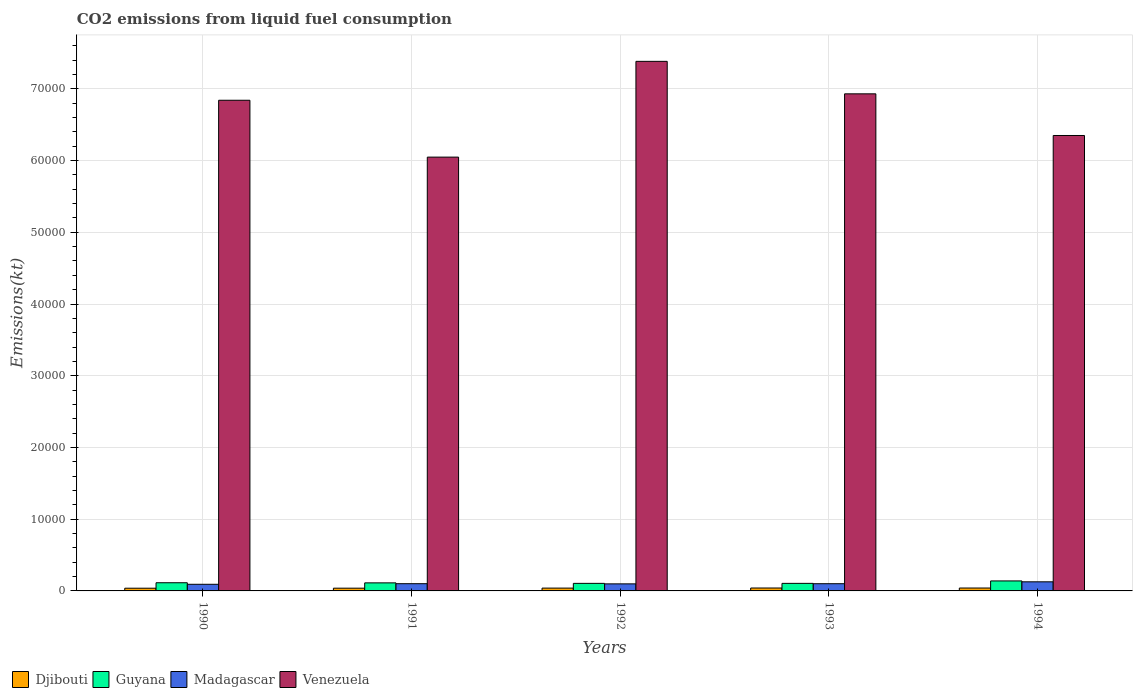How many groups of bars are there?
Offer a terse response. 5. Are the number of bars per tick equal to the number of legend labels?
Ensure brevity in your answer.  Yes. How many bars are there on the 2nd tick from the left?
Your response must be concise. 4. How many bars are there on the 1st tick from the right?
Give a very brief answer. 4. What is the amount of CO2 emitted in Madagascar in 1991?
Provide a short and direct response. 1008.42. Across all years, what is the maximum amount of CO2 emitted in Venezuela?
Offer a terse response. 7.38e+04. Across all years, what is the minimum amount of CO2 emitted in Djibouti?
Your answer should be compact. 377.7. What is the total amount of CO2 emitted in Djibouti in the graph?
Your response must be concise. 1961.85. What is the difference between the amount of CO2 emitted in Venezuela in 1992 and that in 1993?
Offer a very short reply. 4528.74. What is the difference between the amount of CO2 emitted in Djibouti in 1993 and the amount of CO2 emitted in Guyana in 1990?
Your answer should be very brief. -733.4. What is the average amount of CO2 emitted in Guyana per year?
Provide a succinct answer. 1152.17. In the year 1994, what is the difference between the amount of CO2 emitted in Venezuela and amount of CO2 emitted in Djibouti?
Ensure brevity in your answer.  6.31e+04. What is the ratio of the amount of CO2 emitted in Venezuela in 1990 to that in 1991?
Give a very brief answer. 1.13. What is the difference between the highest and the second highest amount of CO2 emitted in Venezuela?
Ensure brevity in your answer.  4528.74. What is the difference between the highest and the lowest amount of CO2 emitted in Madagascar?
Your answer should be compact. 344.7. Is it the case that in every year, the sum of the amount of CO2 emitted in Madagascar and amount of CO2 emitted in Venezuela is greater than the sum of amount of CO2 emitted in Djibouti and amount of CO2 emitted in Guyana?
Provide a short and direct response. Yes. What does the 3rd bar from the left in 1991 represents?
Keep it short and to the point. Madagascar. What does the 2nd bar from the right in 1990 represents?
Your answer should be very brief. Madagascar. Is it the case that in every year, the sum of the amount of CO2 emitted in Venezuela and amount of CO2 emitted in Madagascar is greater than the amount of CO2 emitted in Guyana?
Make the answer very short. Yes. How many bars are there?
Your answer should be compact. 20. Are all the bars in the graph horizontal?
Your answer should be very brief. No. How many years are there in the graph?
Provide a succinct answer. 5. Are the values on the major ticks of Y-axis written in scientific E-notation?
Ensure brevity in your answer.  No. How are the legend labels stacked?
Offer a very short reply. Horizontal. What is the title of the graph?
Ensure brevity in your answer.  CO2 emissions from liquid fuel consumption. Does "United States" appear as one of the legend labels in the graph?
Your response must be concise. No. What is the label or title of the X-axis?
Make the answer very short. Years. What is the label or title of the Y-axis?
Your answer should be compact. Emissions(kt). What is the Emissions(kt) of Djibouti in 1990?
Offer a terse response. 377.7. What is the Emissions(kt) of Guyana in 1990?
Offer a terse response. 1140.44. What is the Emissions(kt) in Madagascar in 1990?
Keep it short and to the point. 924.08. What is the Emissions(kt) of Venezuela in 1990?
Offer a terse response. 6.84e+04. What is the Emissions(kt) in Djibouti in 1991?
Make the answer very short. 381.37. What is the Emissions(kt) of Guyana in 1991?
Your answer should be compact. 1122.1. What is the Emissions(kt) of Madagascar in 1991?
Keep it short and to the point. 1008.42. What is the Emissions(kt) in Venezuela in 1991?
Your answer should be very brief. 6.05e+04. What is the Emissions(kt) of Djibouti in 1992?
Ensure brevity in your answer.  392.37. What is the Emissions(kt) of Guyana in 1992?
Your response must be concise. 1052.43. What is the Emissions(kt) in Madagascar in 1992?
Provide a succinct answer. 982.76. What is the Emissions(kt) of Venezuela in 1992?
Ensure brevity in your answer.  7.38e+04. What is the Emissions(kt) in Djibouti in 1993?
Offer a very short reply. 407.04. What is the Emissions(kt) in Guyana in 1993?
Your answer should be compact. 1052.43. What is the Emissions(kt) of Madagascar in 1993?
Keep it short and to the point. 1004.76. What is the Emissions(kt) of Venezuela in 1993?
Keep it short and to the point. 6.93e+04. What is the Emissions(kt) in Djibouti in 1994?
Your answer should be compact. 403.37. What is the Emissions(kt) in Guyana in 1994?
Give a very brief answer. 1393.46. What is the Emissions(kt) in Madagascar in 1994?
Provide a succinct answer. 1268.78. What is the Emissions(kt) of Venezuela in 1994?
Your answer should be compact. 6.35e+04. Across all years, what is the maximum Emissions(kt) in Djibouti?
Make the answer very short. 407.04. Across all years, what is the maximum Emissions(kt) in Guyana?
Offer a very short reply. 1393.46. Across all years, what is the maximum Emissions(kt) in Madagascar?
Provide a short and direct response. 1268.78. Across all years, what is the maximum Emissions(kt) in Venezuela?
Your answer should be compact. 7.38e+04. Across all years, what is the minimum Emissions(kt) in Djibouti?
Offer a terse response. 377.7. Across all years, what is the minimum Emissions(kt) of Guyana?
Offer a terse response. 1052.43. Across all years, what is the minimum Emissions(kt) of Madagascar?
Provide a succinct answer. 924.08. Across all years, what is the minimum Emissions(kt) in Venezuela?
Offer a very short reply. 6.05e+04. What is the total Emissions(kt) in Djibouti in the graph?
Ensure brevity in your answer.  1961.85. What is the total Emissions(kt) of Guyana in the graph?
Provide a short and direct response. 5760.86. What is the total Emissions(kt) of Madagascar in the graph?
Make the answer very short. 5188.81. What is the total Emissions(kt) of Venezuela in the graph?
Offer a very short reply. 3.36e+05. What is the difference between the Emissions(kt) in Djibouti in 1990 and that in 1991?
Offer a very short reply. -3.67. What is the difference between the Emissions(kt) of Guyana in 1990 and that in 1991?
Your answer should be compact. 18.34. What is the difference between the Emissions(kt) of Madagascar in 1990 and that in 1991?
Make the answer very short. -84.34. What is the difference between the Emissions(kt) in Venezuela in 1990 and that in 1991?
Make the answer very short. 7928.05. What is the difference between the Emissions(kt) in Djibouti in 1990 and that in 1992?
Your answer should be very brief. -14.67. What is the difference between the Emissions(kt) in Guyana in 1990 and that in 1992?
Keep it short and to the point. 88.01. What is the difference between the Emissions(kt) in Madagascar in 1990 and that in 1992?
Offer a terse response. -58.67. What is the difference between the Emissions(kt) in Venezuela in 1990 and that in 1992?
Your answer should be compact. -5423.49. What is the difference between the Emissions(kt) in Djibouti in 1990 and that in 1993?
Provide a succinct answer. -29.34. What is the difference between the Emissions(kt) of Guyana in 1990 and that in 1993?
Make the answer very short. 88.01. What is the difference between the Emissions(kt) of Madagascar in 1990 and that in 1993?
Offer a terse response. -80.67. What is the difference between the Emissions(kt) of Venezuela in 1990 and that in 1993?
Give a very brief answer. -894.75. What is the difference between the Emissions(kt) in Djibouti in 1990 and that in 1994?
Provide a short and direct response. -25.67. What is the difference between the Emissions(kt) of Guyana in 1990 and that in 1994?
Give a very brief answer. -253.02. What is the difference between the Emissions(kt) of Madagascar in 1990 and that in 1994?
Keep it short and to the point. -344.7. What is the difference between the Emissions(kt) of Venezuela in 1990 and that in 1994?
Your answer should be very brief. 4913.78. What is the difference between the Emissions(kt) of Djibouti in 1991 and that in 1992?
Your answer should be very brief. -11. What is the difference between the Emissions(kt) in Guyana in 1991 and that in 1992?
Ensure brevity in your answer.  69.67. What is the difference between the Emissions(kt) in Madagascar in 1991 and that in 1992?
Give a very brief answer. 25.67. What is the difference between the Emissions(kt) in Venezuela in 1991 and that in 1992?
Offer a very short reply. -1.34e+04. What is the difference between the Emissions(kt) of Djibouti in 1991 and that in 1993?
Offer a terse response. -25.67. What is the difference between the Emissions(kt) of Guyana in 1991 and that in 1993?
Make the answer very short. 69.67. What is the difference between the Emissions(kt) in Madagascar in 1991 and that in 1993?
Offer a very short reply. 3.67. What is the difference between the Emissions(kt) of Venezuela in 1991 and that in 1993?
Offer a very short reply. -8822.8. What is the difference between the Emissions(kt) in Djibouti in 1991 and that in 1994?
Keep it short and to the point. -22. What is the difference between the Emissions(kt) in Guyana in 1991 and that in 1994?
Your answer should be very brief. -271.36. What is the difference between the Emissions(kt) in Madagascar in 1991 and that in 1994?
Ensure brevity in your answer.  -260.36. What is the difference between the Emissions(kt) in Venezuela in 1991 and that in 1994?
Give a very brief answer. -3014.27. What is the difference between the Emissions(kt) of Djibouti in 1992 and that in 1993?
Your answer should be very brief. -14.67. What is the difference between the Emissions(kt) in Guyana in 1992 and that in 1993?
Offer a very short reply. 0. What is the difference between the Emissions(kt) in Madagascar in 1992 and that in 1993?
Offer a very short reply. -22. What is the difference between the Emissions(kt) of Venezuela in 1992 and that in 1993?
Provide a succinct answer. 4528.74. What is the difference between the Emissions(kt) of Djibouti in 1992 and that in 1994?
Give a very brief answer. -11. What is the difference between the Emissions(kt) of Guyana in 1992 and that in 1994?
Provide a succinct answer. -341.03. What is the difference between the Emissions(kt) of Madagascar in 1992 and that in 1994?
Ensure brevity in your answer.  -286.03. What is the difference between the Emissions(kt) of Venezuela in 1992 and that in 1994?
Provide a succinct answer. 1.03e+04. What is the difference between the Emissions(kt) of Djibouti in 1993 and that in 1994?
Your response must be concise. 3.67. What is the difference between the Emissions(kt) of Guyana in 1993 and that in 1994?
Ensure brevity in your answer.  -341.03. What is the difference between the Emissions(kt) in Madagascar in 1993 and that in 1994?
Give a very brief answer. -264.02. What is the difference between the Emissions(kt) in Venezuela in 1993 and that in 1994?
Give a very brief answer. 5808.53. What is the difference between the Emissions(kt) of Djibouti in 1990 and the Emissions(kt) of Guyana in 1991?
Offer a terse response. -744.4. What is the difference between the Emissions(kt) in Djibouti in 1990 and the Emissions(kt) in Madagascar in 1991?
Keep it short and to the point. -630.72. What is the difference between the Emissions(kt) of Djibouti in 1990 and the Emissions(kt) of Venezuela in 1991?
Offer a very short reply. -6.01e+04. What is the difference between the Emissions(kt) of Guyana in 1990 and the Emissions(kt) of Madagascar in 1991?
Your answer should be compact. 132.01. What is the difference between the Emissions(kt) of Guyana in 1990 and the Emissions(kt) of Venezuela in 1991?
Your response must be concise. -5.93e+04. What is the difference between the Emissions(kt) of Madagascar in 1990 and the Emissions(kt) of Venezuela in 1991?
Your answer should be compact. -5.96e+04. What is the difference between the Emissions(kt) in Djibouti in 1990 and the Emissions(kt) in Guyana in 1992?
Make the answer very short. -674.73. What is the difference between the Emissions(kt) in Djibouti in 1990 and the Emissions(kt) in Madagascar in 1992?
Your response must be concise. -605.05. What is the difference between the Emissions(kt) in Djibouti in 1990 and the Emissions(kt) in Venezuela in 1992?
Provide a succinct answer. -7.35e+04. What is the difference between the Emissions(kt) in Guyana in 1990 and the Emissions(kt) in Madagascar in 1992?
Ensure brevity in your answer.  157.68. What is the difference between the Emissions(kt) of Guyana in 1990 and the Emissions(kt) of Venezuela in 1992?
Offer a very short reply. -7.27e+04. What is the difference between the Emissions(kt) in Madagascar in 1990 and the Emissions(kt) in Venezuela in 1992?
Offer a terse response. -7.29e+04. What is the difference between the Emissions(kt) in Djibouti in 1990 and the Emissions(kt) in Guyana in 1993?
Provide a short and direct response. -674.73. What is the difference between the Emissions(kt) in Djibouti in 1990 and the Emissions(kt) in Madagascar in 1993?
Ensure brevity in your answer.  -627.06. What is the difference between the Emissions(kt) in Djibouti in 1990 and the Emissions(kt) in Venezuela in 1993?
Keep it short and to the point. -6.89e+04. What is the difference between the Emissions(kt) in Guyana in 1990 and the Emissions(kt) in Madagascar in 1993?
Your answer should be very brief. 135.68. What is the difference between the Emissions(kt) in Guyana in 1990 and the Emissions(kt) in Venezuela in 1993?
Your answer should be compact. -6.82e+04. What is the difference between the Emissions(kt) of Madagascar in 1990 and the Emissions(kt) of Venezuela in 1993?
Ensure brevity in your answer.  -6.84e+04. What is the difference between the Emissions(kt) of Djibouti in 1990 and the Emissions(kt) of Guyana in 1994?
Offer a very short reply. -1015.76. What is the difference between the Emissions(kt) of Djibouti in 1990 and the Emissions(kt) of Madagascar in 1994?
Your response must be concise. -891.08. What is the difference between the Emissions(kt) of Djibouti in 1990 and the Emissions(kt) of Venezuela in 1994?
Provide a short and direct response. -6.31e+04. What is the difference between the Emissions(kt) in Guyana in 1990 and the Emissions(kt) in Madagascar in 1994?
Offer a terse response. -128.34. What is the difference between the Emissions(kt) in Guyana in 1990 and the Emissions(kt) in Venezuela in 1994?
Ensure brevity in your answer.  -6.24e+04. What is the difference between the Emissions(kt) in Madagascar in 1990 and the Emissions(kt) in Venezuela in 1994?
Keep it short and to the point. -6.26e+04. What is the difference between the Emissions(kt) of Djibouti in 1991 and the Emissions(kt) of Guyana in 1992?
Make the answer very short. -671.06. What is the difference between the Emissions(kt) of Djibouti in 1991 and the Emissions(kt) of Madagascar in 1992?
Your response must be concise. -601.39. What is the difference between the Emissions(kt) in Djibouti in 1991 and the Emissions(kt) in Venezuela in 1992?
Provide a succinct answer. -7.35e+04. What is the difference between the Emissions(kt) in Guyana in 1991 and the Emissions(kt) in Madagascar in 1992?
Offer a terse response. 139.35. What is the difference between the Emissions(kt) of Guyana in 1991 and the Emissions(kt) of Venezuela in 1992?
Keep it short and to the point. -7.27e+04. What is the difference between the Emissions(kt) in Madagascar in 1991 and the Emissions(kt) in Venezuela in 1992?
Provide a short and direct response. -7.28e+04. What is the difference between the Emissions(kt) in Djibouti in 1991 and the Emissions(kt) in Guyana in 1993?
Your answer should be compact. -671.06. What is the difference between the Emissions(kt) in Djibouti in 1991 and the Emissions(kt) in Madagascar in 1993?
Make the answer very short. -623.39. What is the difference between the Emissions(kt) in Djibouti in 1991 and the Emissions(kt) in Venezuela in 1993?
Make the answer very short. -6.89e+04. What is the difference between the Emissions(kt) in Guyana in 1991 and the Emissions(kt) in Madagascar in 1993?
Keep it short and to the point. 117.34. What is the difference between the Emissions(kt) of Guyana in 1991 and the Emissions(kt) of Venezuela in 1993?
Offer a terse response. -6.82e+04. What is the difference between the Emissions(kt) in Madagascar in 1991 and the Emissions(kt) in Venezuela in 1993?
Give a very brief answer. -6.83e+04. What is the difference between the Emissions(kt) in Djibouti in 1991 and the Emissions(kt) in Guyana in 1994?
Make the answer very short. -1012.09. What is the difference between the Emissions(kt) in Djibouti in 1991 and the Emissions(kt) in Madagascar in 1994?
Give a very brief answer. -887.41. What is the difference between the Emissions(kt) of Djibouti in 1991 and the Emissions(kt) of Venezuela in 1994?
Make the answer very short. -6.31e+04. What is the difference between the Emissions(kt) of Guyana in 1991 and the Emissions(kt) of Madagascar in 1994?
Offer a very short reply. -146.68. What is the difference between the Emissions(kt) of Guyana in 1991 and the Emissions(kt) of Venezuela in 1994?
Offer a very short reply. -6.24e+04. What is the difference between the Emissions(kt) in Madagascar in 1991 and the Emissions(kt) in Venezuela in 1994?
Your response must be concise. -6.25e+04. What is the difference between the Emissions(kt) in Djibouti in 1992 and the Emissions(kt) in Guyana in 1993?
Your answer should be very brief. -660.06. What is the difference between the Emissions(kt) in Djibouti in 1992 and the Emissions(kt) in Madagascar in 1993?
Provide a succinct answer. -612.39. What is the difference between the Emissions(kt) in Djibouti in 1992 and the Emissions(kt) in Venezuela in 1993?
Provide a short and direct response. -6.89e+04. What is the difference between the Emissions(kt) in Guyana in 1992 and the Emissions(kt) in Madagascar in 1993?
Your answer should be very brief. 47.67. What is the difference between the Emissions(kt) of Guyana in 1992 and the Emissions(kt) of Venezuela in 1993?
Provide a succinct answer. -6.83e+04. What is the difference between the Emissions(kt) in Madagascar in 1992 and the Emissions(kt) in Venezuela in 1993?
Give a very brief answer. -6.83e+04. What is the difference between the Emissions(kt) in Djibouti in 1992 and the Emissions(kt) in Guyana in 1994?
Ensure brevity in your answer.  -1001.09. What is the difference between the Emissions(kt) of Djibouti in 1992 and the Emissions(kt) of Madagascar in 1994?
Provide a short and direct response. -876.41. What is the difference between the Emissions(kt) of Djibouti in 1992 and the Emissions(kt) of Venezuela in 1994?
Your response must be concise. -6.31e+04. What is the difference between the Emissions(kt) of Guyana in 1992 and the Emissions(kt) of Madagascar in 1994?
Give a very brief answer. -216.35. What is the difference between the Emissions(kt) of Guyana in 1992 and the Emissions(kt) of Venezuela in 1994?
Offer a terse response. -6.24e+04. What is the difference between the Emissions(kt) in Madagascar in 1992 and the Emissions(kt) in Venezuela in 1994?
Your answer should be very brief. -6.25e+04. What is the difference between the Emissions(kt) of Djibouti in 1993 and the Emissions(kt) of Guyana in 1994?
Provide a succinct answer. -986.42. What is the difference between the Emissions(kt) in Djibouti in 1993 and the Emissions(kt) in Madagascar in 1994?
Ensure brevity in your answer.  -861.75. What is the difference between the Emissions(kt) of Djibouti in 1993 and the Emissions(kt) of Venezuela in 1994?
Provide a short and direct response. -6.31e+04. What is the difference between the Emissions(kt) in Guyana in 1993 and the Emissions(kt) in Madagascar in 1994?
Your answer should be compact. -216.35. What is the difference between the Emissions(kt) of Guyana in 1993 and the Emissions(kt) of Venezuela in 1994?
Give a very brief answer. -6.24e+04. What is the difference between the Emissions(kt) in Madagascar in 1993 and the Emissions(kt) in Venezuela in 1994?
Provide a succinct answer. -6.25e+04. What is the average Emissions(kt) in Djibouti per year?
Provide a short and direct response. 392.37. What is the average Emissions(kt) of Guyana per year?
Offer a very short reply. 1152.17. What is the average Emissions(kt) of Madagascar per year?
Provide a short and direct response. 1037.76. What is the average Emissions(kt) of Venezuela per year?
Your answer should be compact. 6.71e+04. In the year 1990, what is the difference between the Emissions(kt) in Djibouti and Emissions(kt) in Guyana?
Your answer should be very brief. -762.74. In the year 1990, what is the difference between the Emissions(kt) in Djibouti and Emissions(kt) in Madagascar?
Offer a very short reply. -546.38. In the year 1990, what is the difference between the Emissions(kt) of Djibouti and Emissions(kt) of Venezuela?
Provide a succinct answer. -6.80e+04. In the year 1990, what is the difference between the Emissions(kt) in Guyana and Emissions(kt) in Madagascar?
Offer a very short reply. 216.35. In the year 1990, what is the difference between the Emissions(kt) of Guyana and Emissions(kt) of Venezuela?
Keep it short and to the point. -6.73e+04. In the year 1990, what is the difference between the Emissions(kt) in Madagascar and Emissions(kt) in Venezuela?
Offer a terse response. -6.75e+04. In the year 1991, what is the difference between the Emissions(kt) in Djibouti and Emissions(kt) in Guyana?
Keep it short and to the point. -740.73. In the year 1991, what is the difference between the Emissions(kt) in Djibouti and Emissions(kt) in Madagascar?
Ensure brevity in your answer.  -627.06. In the year 1991, what is the difference between the Emissions(kt) of Djibouti and Emissions(kt) of Venezuela?
Ensure brevity in your answer.  -6.01e+04. In the year 1991, what is the difference between the Emissions(kt) of Guyana and Emissions(kt) of Madagascar?
Make the answer very short. 113.68. In the year 1991, what is the difference between the Emissions(kt) in Guyana and Emissions(kt) in Venezuela?
Your answer should be compact. -5.94e+04. In the year 1991, what is the difference between the Emissions(kt) of Madagascar and Emissions(kt) of Venezuela?
Provide a succinct answer. -5.95e+04. In the year 1992, what is the difference between the Emissions(kt) in Djibouti and Emissions(kt) in Guyana?
Keep it short and to the point. -660.06. In the year 1992, what is the difference between the Emissions(kt) in Djibouti and Emissions(kt) in Madagascar?
Your answer should be compact. -590.39. In the year 1992, what is the difference between the Emissions(kt) in Djibouti and Emissions(kt) in Venezuela?
Make the answer very short. -7.34e+04. In the year 1992, what is the difference between the Emissions(kt) of Guyana and Emissions(kt) of Madagascar?
Give a very brief answer. 69.67. In the year 1992, what is the difference between the Emissions(kt) of Guyana and Emissions(kt) of Venezuela?
Keep it short and to the point. -7.28e+04. In the year 1992, what is the difference between the Emissions(kt) in Madagascar and Emissions(kt) in Venezuela?
Your answer should be compact. -7.28e+04. In the year 1993, what is the difference between the Emissions(kt) in Djibouti and Emissions(kt) in Guyana?
Offer a terse response. -645.39. In the year 1993, what is the difference between the Emissions(kt) of Djibouti and Emissions(kt) of Madagascar?
Offer a very short reply. -597.72. In the year 1993, what is the difference between the Emissions(kt) in Djibouti and Emissions(kt) in Venezuela?
Keep it short and to the point. -6.89e+04. In the year 1993, what is the difference between the Emissions(kt) in Guyana and Emissions(kt) in Madagascar?
Your answer should be very brief. 47.67. In the year 1993, what is the difference between the Emissions(kt) in Guyana and Emissions(kt) in Venezuela?
Offer a very short reply. -6.83e+04. In the year 1993, what is the difference between the Emissions(kt) of Madagascar and Emissions(kt) of Venezuela?
Provide a short and direct response. -6.83e+04. In the year 1994, what is the difference between the Emissions(kt) in Djibouti and Emissions(kt) in Guyana?
Offer a terse response. -990.09. In the year 1994, what is the difference between the Emissions(kt) of Djibouti and Emissions(kt) of Madagascar?
Ensure brevity in your answer.  -865.41. In the year 1994, what is the difference between the Emissions(kt) of Djibouti and Emissions(kt) of Venezuela?
Give a very brief answer. -6.31e+04. In the year 1994, what is the difference between the Emissions(kt) in Guyana and Emissions(kt) in Madagascar?
Make the answer very short. 124.68. In the year 1994, what is the difference between the Emissions(kt) in Guyana and Emissions(kt) in Venezuela?
Keep it short and to the point. -6.21e+04. In the year 1994, what is the difference between the Emissions(kt) of Madagascar and Emissions(kt) of Venezuela?
Offer a terse response. -6.22e+04. What is the ratio of the Emissions(kt) of Djibouti in 1990 to that in 1991?
Your response must be concise. 0.99. What is the ratio of the Emissions(kt) of Guyana in 1990 to that in 1991?
Offer a terse response. 1.02. What is the ratio of the Emissions(kt) in Madagascar in 1990 to that in 1991?
Provide a succinct answer. 0.92. What is the ratio of the Emissions(kt) of Venezuela in 1990 to that in 1991?
Make the answer very short. 1.13. What is the ratio of the Emissions(kt) of Djibouti in 1990 to that in 1992?
Offer a terse response. 0.96. What is the ratio of the Emissions(kt) in Guyana in 1990 to that in 1992?
Offer a very short reply. 1.08. What is the ratio of the Emissions(kt) in Madagascar in 1990 to that in 1992?
Provide a short and direct response. 0.94. What is the ratio of the Emissions(kt) in Venezuela in 1990 to that in 1992?
Make the answer very short. 0.93. What is the ratio of the Emissions(kt) in Djibouti in 1990 to that in 1993?
Provide a succinct answer. 0.93. What is the ratio of the Emissions(kt) of Guyana in 1990 to that in 1993?
Ensure brevity in your answer.  1.08. What is the ratio of the Emissions(kt) of Madagascar in 1990 to that in 1993?
Your answer should be very brief. 0.92. What is the ratio of the Emissions(kt) of Venezuela in 1990 to that in 1993?
Your answer should be very brief. 0.99. What is the ratio of the Emissions(kt) in Djibouti in 1990 to that in 1994?
Offer a terse response. 0.94. What is the ratio of the Emissions(kt) of Guyana in 1990 to that in 1994?
Keep it short and to the point. 0.82. What is the ratio of the Emissions(kt) in Madagascar in 1990 to that in 1994?
Your response must be concise. 0.73. What is the ratio of the Emissions(kt) of Venezuela in 1990 to that in 1994?
Provide a short and direct response. 1.08. What is the ratio of the Emissions(kt) of Djibouti in 1991 to that in 1992?
Provide a succinct answer. 0.97. What is the ratio of the Emissions(kt) in Guyana in 1991 to that in 1992?
Offer a very short reply. 1.07. What is the ratio of the Emissions(kt) in Madagascar in 1991 to that in 1992?
Your response must be concise. 1.03. What is the ratio of the Emissions(kt) in Venezuela in 1991 to that in 1992?
Give a very brief answer. 0.82. What is the ratio of the Emissions(kt) of Djibouti in 1991 to that in 1993?
Provide a succinct answer. 0.94. What is the ratio of the Emissions(kt) of Guyana in 1991 to that in 1993?
Your answer should be compact. 1.07. What is the ratio of the Emissions(kt) of Madagascar in 1991 to that in 1993?
Your answer should be very brief. 1. What is the ratio of the Emissions(kt) in Venezuela in 1991 to that in 1993?
Offer a very short reply. 0.87. What is the ratio of the Emissions(kt) in Djibouti in 1991 to that in 1994?
Give a very brief answer. 0.95. What is the ratio of the Emissions(kt) in Guyana in 1991 to that in 1994?
Your answer should be compact. 0.81. What is the ratio of the Emissions(kt) of Madagascar in 1991 to that in 1994?
Give a very brief answer. 0.79. What is the ratio of the Emissions(kt) in Venezuela in 1991 to that in 1994?
Make the answer very short. 0.95. What is the ratio of the Emissions(kt) of Guyana in 1992 to that in 1993?
Your answer should be compact. 1. What is the ratio of the Emissions(kt) of Madagascar in 1992 to that in 1993?
Ensure brevity in your answer.  0.98. What is the ratio of the Emissions(kt) in Venezuela in 1992 to that in 1993?
Your response must be concise. 1.07. What is the ratio of the Emissions(kt) in Djibouti in 1992 to that in 1994?
Offer a terse response. 0.97. What is the ratio of the Emissions(kt) of Guyana in 1992 to that in 1994?
Provide a succinct answer. 0.76. What is the ratio of the Emissions(kt) in Madagascar in 1992 to that in 1994?
Ensure brevity in your answer.  0.77. What is the ratio of the Emissions(kt) in Venezuela in 1992 to that in 1994?
Give a very brief answer. 1.16. What is the ratio of the Emissions(kt) in Djibouti in 1993 to that in 1994?
Make the answer very short. 1.01. What is the ratio of the Emissions(kt) of Guyana in 1993 to that in 1994?
Your answer should be compact. 0.76. What is the ratio of the Emissions(kt) in Madagascar in 1993 to that in 1994?
Provide a succinct answer. 0.79. What is the ratio of the Emissions(kt) in Venezuela in 1993 to that in 1994?
Offer a terse response. 1.09. What is the difference between the highest and the second highest Emissions(kt) of Djibouti?
Keep it short and to the point. 3.67. What is the difference between the highest and the second highest Emissions(kt) in Guyana?
Make the answer very short. 253.02. What is the difference between the highest and the second highest Emissions(kt) of Madagascar?
Provide a short and direct response. 260.36. What is the difference between the highest and the second highest Emissions(kt) in Venezuela?
Keep it short and to the point. 4528.74. What is the difference between the highest and the lowest Emissions(kt) in Djibouti?
Make the answer very short. 29.34. What is the difference between the highest and the lowest Emissions(kt) in Guyana?
Your answer should be compact. 341.03. What is the difference between the highest and the lowest Emissions(kt) of Madagascar?
Make the answer very short. 344.7. What is the difference between the highest and the lowest Emissions(kt) of Venezuela?
Your response must be concise. 1.34e+04. 